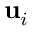Convert formula to latex. <formula><loc_0><loc_0><loc_500><loc_500>u _ { i }</formula> 